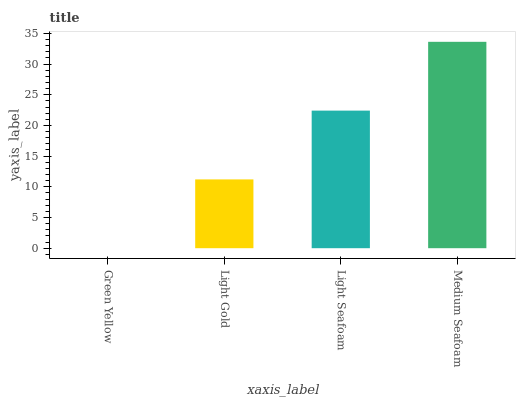Is Green Yellow the minimum?
Answer yes or no. Yes. Is Medium Seafoam the maximum?
Answer yes or no. Yes. Is Light Gold the minimum?
Answer yes or no. No. Is Light Gold the maximum?
Answer yes or no. No. Is Light Gold greater than Green Yellow?
Answer yes or no. Yes. Is Green Yellow less than Light Gold?
Answer yes or no. Yes. Is Green Yellow greater than Light Gold?
Answer yes or no. No. Is Light Gold less than Green Yellow?
Answer yes or no. No. Is Light Seafoam the high median?
Answer yes or no. Yes. Is Light Gold the low median?
Answer yes or no. Yes. Is Light Gold the high median?
Answer yes or no. No. Is Medium Seafoam the low median?
Answer yes or no. No. 